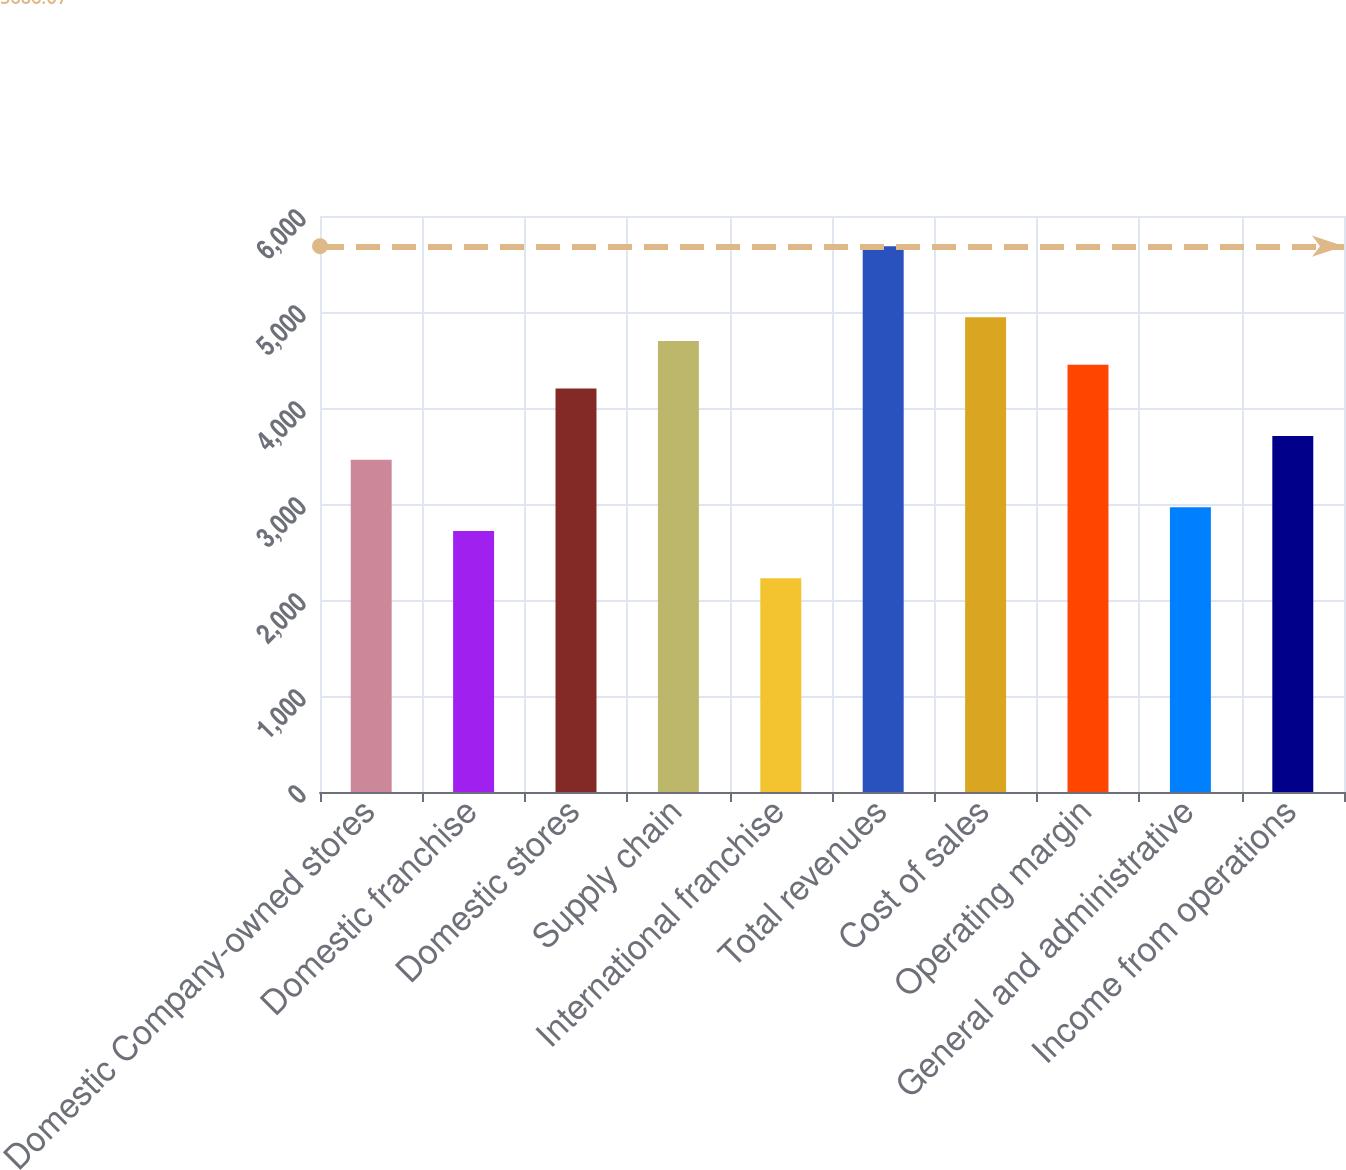Convert chart to OTSL. <chart><loc_0><loc_0><loc_500><loc_500><bar_chart><fcel>Domestic Company-owned stores<fcel>Domestic franchise<fcel>Domestic stores<fcel>Supply chain<fcel>International franchise<fcel>Total revenues<fcel>Cost of sales<fcel>Operating margin<fcel>General and administrative<fcel>Income from operations<nl><fcel>3461.36<fcel>2719.79<fcel>4202.93<fcel>4697.31<fcel>2225.41<fcel>5686.07<fcel>4944.5<fcel>4450.12<fcel>2966.98<fcel>3708.55<nl></chart> 